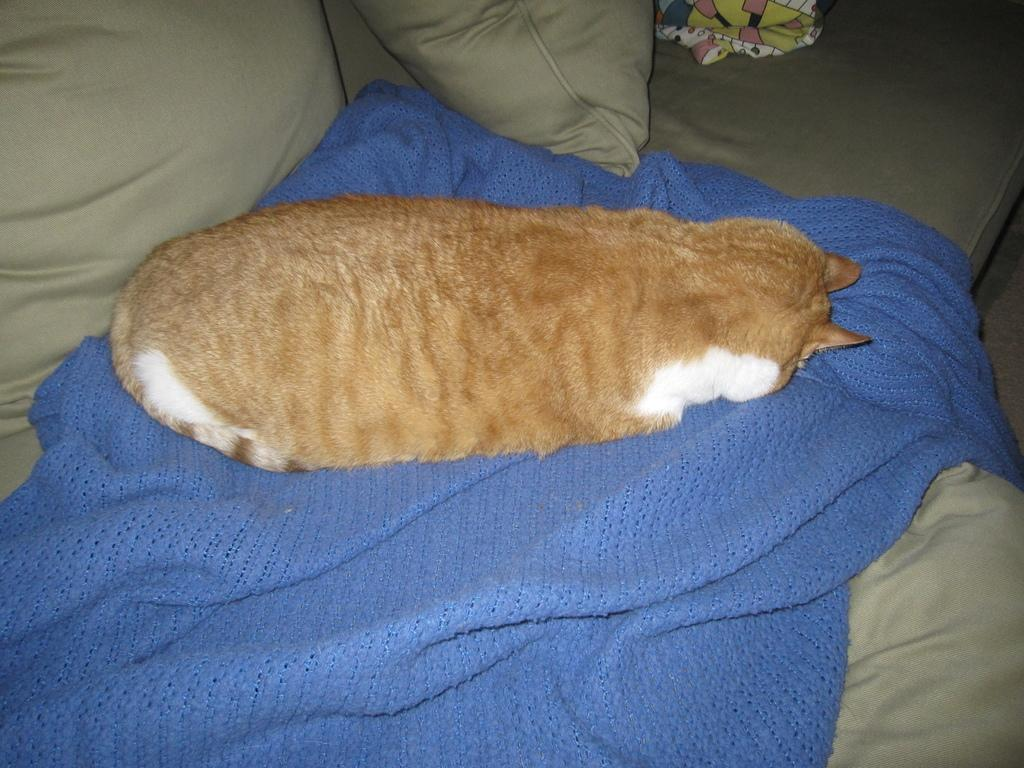What animal is present in the image? There is a cat in the image. Where is the cat sitting? The cat is sitting on a cloth. What is the cloth placed on? The cloth is on a couch. What else can be seen on the couch? There are pillows and another cloth on the couch. What type of corn is being used as a decoration on the couch? There is no corn present in the image; it features a cat sitting on a cloth on a couch with pillows and another cloth. 